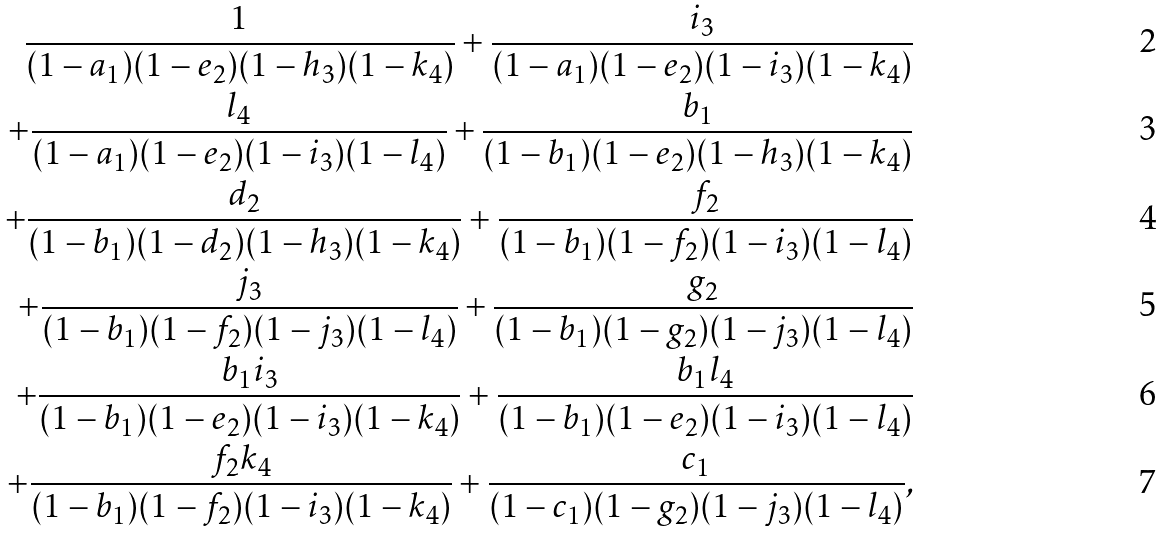<formula> <loc_0><loc_0><loc_500><loc_500>\frac { 1 } { ( 1 - a _ { 1 } ) ( 1 - e _ { 2 } ) ( 1 - h _ { 3 } ) ( 1 - k _ { 4 } ) } + \frac { i _ { 3 } } { ( 1 - a _ { 1 } ) ( 1 - e _ { 2 } ) ( 1 - i _ { 3 } ) ( 1 - k _ { 4 } ) } \\ + \frac { l _ { 4 } } { ( 1 - a _ { 1 } ) ( 1 - e _ { 2 } ) ( 1 - i _ { 3 } ) ( 1 - l _ { 4 } ) } + \frac { b _ { 1 } } { ( 1 - b _ { 1 } ) ( 1 - e _ { 2 } ) ( 1 - h _ { 3 } ) ( 1 - k _ { 4 } ) } \\ + \frac { d _ { 2 } } { ( 1 - b _ { 1 } ) ( 1 - d _ { 2 } ) ( 1 - h _ { 3 } ) ( 1 - k _ { 4 } ) } + \frac { f _ { 2 } } { ( 1 - b _ { 1 } ) ( 1 - f _ { 2 } ) ( 1 - i _ { 3 } ) ( 1 - l _ { 4 } ) } \\ + \frac { j _ { 3 } } { ( 1 - b _ { 1 } ) ( 1 - f _ { 2 } ) ( 1 - j _ { 3 } ) ( 1 - l _ { 4 } ) } + \frac { g _ { 2 } } { ( 1 - b _ { 1 } ) ( 1 - g _ { 2 } ) ( 1 - j _ { 3 } ) ( 1 - l _ { 4 } ) } \\ + \frac { b _ { 1 } i _ { 3 } } { ( 1 - b _ { 1 } ) ( 1 - e _ { 2 } ) ( 1 - i _ { 3 } ) ( 1 - k _ { 4 } ) } + \frac { b _ { 1 } l _ { 4 } } { ( 1 - b _ { 1 } ) ( 1 - e _ { 2 } ) ( 1 - i _ { 3 } ) ( 1 - l _ { 4 } ) } \\ + \frac { f _ { 2 } k _ { 4 } } { ( 1 - b _ { 1 } ) ( 1 - f _ { 2 } ) ( 1 - i _ { 3 } ) ( 1 - k _ { 4 } ) } + \frac { c _ { 1 } } { ( 1 - c _ { 1 } ) ( 1 - g _ { 2 } ) ( 1 - j _ { 3 } ) ( 1 - l _ { 4 } ) } ,</formula> 